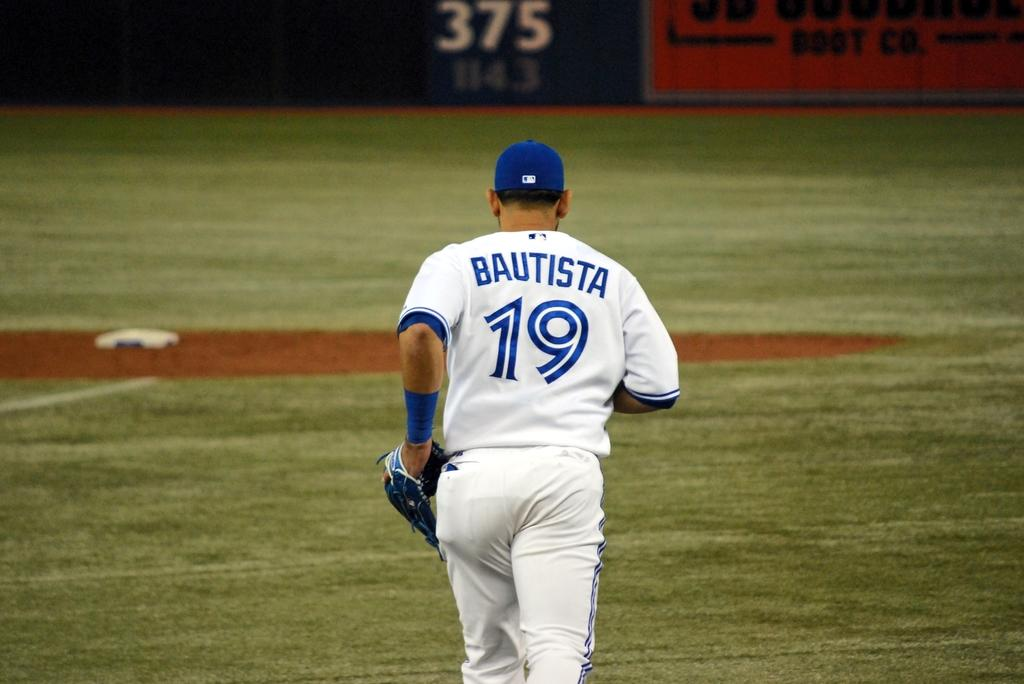Provide a one-sentence caption for the provided image. Baseball player number 19 on the field is Bautista. 